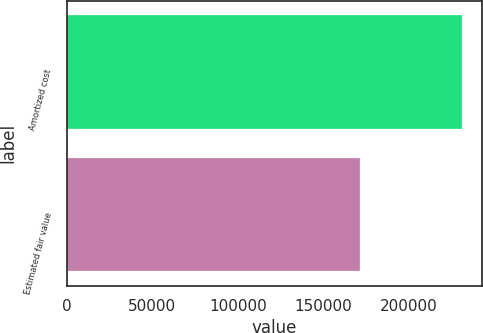Convert chart to OTSL. <chart><loc_0><loc_0><loc_500><loc_500><bar_chart><fcel>Amortized cost<fcel>Estimated fair value<nl><fcel>231040<fcel>171100<nl></chart> 